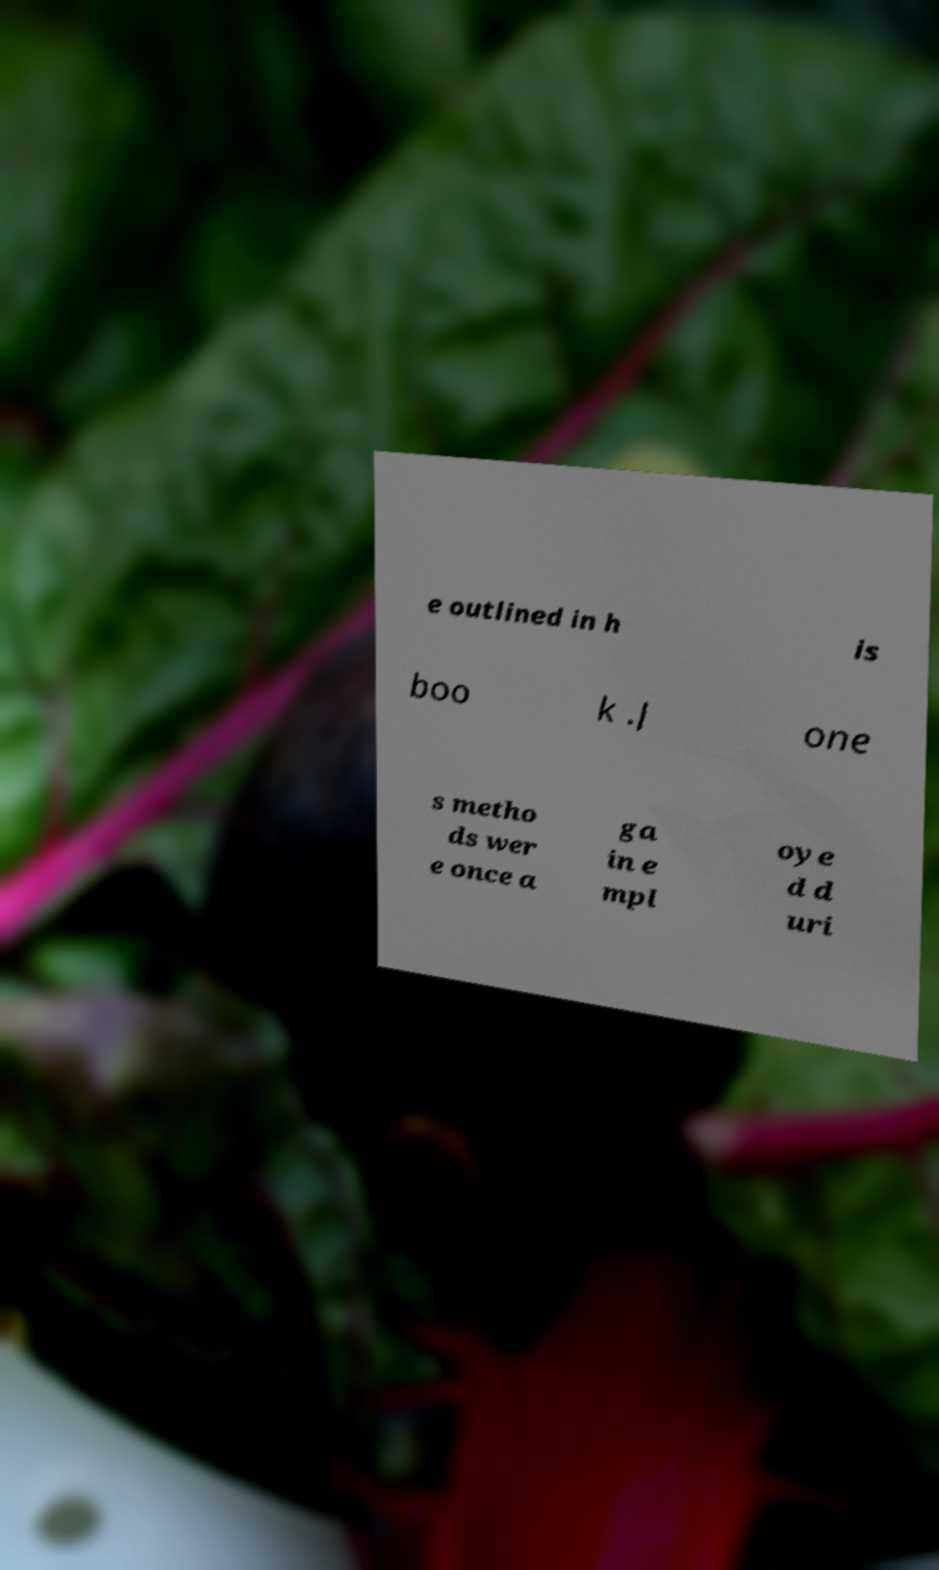Could you extract and type out the text from this image? e outlined in h is boo k .J one s metho ds wer e once a ga in e mpl oye d d uri 